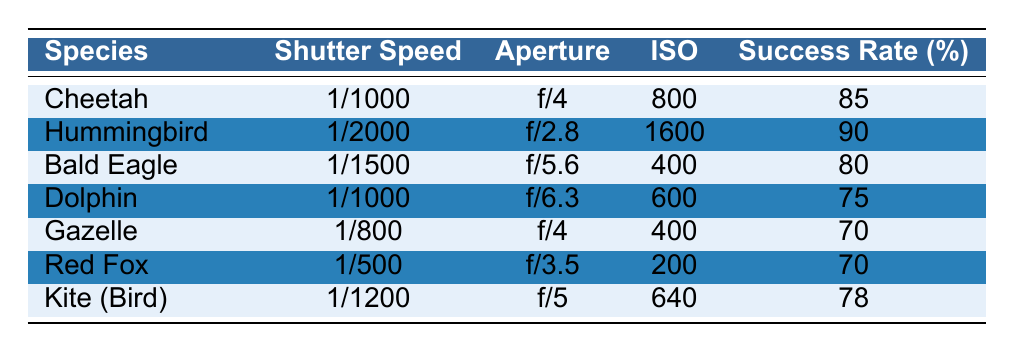What is the success rate for capturing a Cheetah shot? By locating the Cheetah row in the table, we find the success rate value listed directly, which is 85.
Answer: 85 Which species has the highest success rate? By comparing the success rates in the table: Cheetah (85), Hummingbird (90), Bald Eagle (80), Dolphin (75), Gazelle (70), Red Fox (70), and Kite (78), the highest success rate is 90 for the Hummingbird.
Answer: Hummingbird What is the average success rate of all the species listed? To find the average, we first sum the success rates: 85 + 90 + 80 + 75 + 70 + 70 + 78 = 578. There are 7 species, so we divide the sum by the number of species: 578 / 7 = 82.57.
Answer: 82.57 Do all species listed have a success rate over 75%? We check each success rate: Cheetah (85), Hummingbird (90), Bald Eagle (80), Dolphin (75), Gazelle (70), Red Fox (70), Kite (78). The Gazelle and Red Fox both have rates below 75%. Hence, not all species exceed this rate.
Answer: No What is the difference in success rates between the Hummingbird and the Gazelle? The success rate for the Hummingbird is 90, and for the Gazelle, it's 70. The difference is 90 - 70 = 20.
Answer: 20 Which species has the lowest ISO setting and what is its success rate? By scanning through the ISO values, we see the lowest setting is 200, corresponding to the Red Fox, which has a success rate of 70.
Answer: Red Fox, 70 If you used the same settings as for the Bald Eagle, which other species would you expect to have a similar or higher success rate? The Bald Eagle uses a shutter speed of 1/1500, aperture of f/5.6, and ISO of 400 with a 80% success rate. Comparing it with others, Cheetah (85) and Hummingbird (90) have higher success rates. The Dolphin, Gazelle, Red Fox, and Kite have lower rates. Therefore, Cheetah and Hummingbird would be expected to perform better.
Answer: Cheetah, Hummingbird Is there a correlation between shutter speed and success rate across the data? To determine correlations, we would typically plot values; however, by inspection, we see that faster shutter speeds (like those used for Hummingbird at 1/2000) tend to correlate with higher success rates, but not uniformly across all species. A more thorough statistical analysis would be required for confirmation.
Answer: Cannot determine definitively from table 